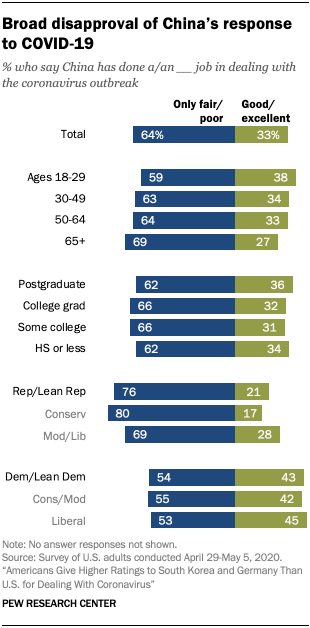Give some essential details in this illustration. Green bar in the Total category represents 33% of the total score. The median value of the first three blue bars from the bottom is 54. 